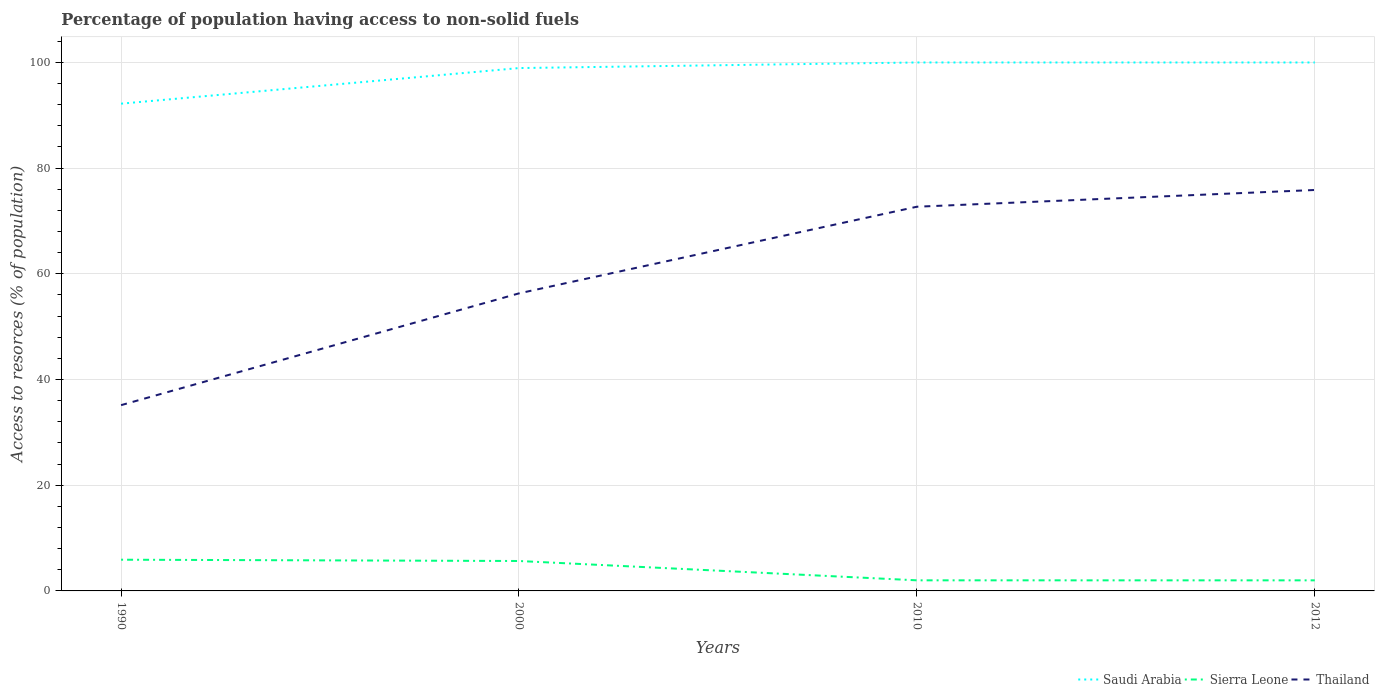How many different coloured lines are there?
Offer a very short reply. 3. Across all years, what is the maximum percentage of population having access to non-solid fuels in Sierra Leone?
Ensure brevity in your answer.  2. In which year was the percentage of population having access to non-solid fuels in Thailand maximum?
Make the answer very short. 1990. What is the total percentage of population having access to non-solid fuels in Thailand in the graph?
Your response must be concise. -19.56. What is the difference between the highest and the second highest percentage of population having access to non-solid fuels in Thailand?
Make the answer very short. 40.71. Is the percentage of population having access to non-solid fuels in Sierra Leone strictly greater than the percentage of population having access to non-solid fuels in Thailand over the years?
Your response must be concise. Yes. How many years are there in the graph?
Offer a very short reply. 4. Are the values on the major ticks of Y-axis written in scientific E-notation?
Keep it short and to the point. No. Does the graph contain any zero values?
Your answer should be compact. No. Does the graph contain grids?
Offer a terse response. Yes. How are the legend labels stacked?
Offer a terse response. Horizontal. What is the title of the graph?
Provide a succinct answer. Percentage of population having access to non-solid fuels. Does "Palau" appear as one of the legend labels in the graph?
Your answer should be compact. No. What is the label or title of the Y-axis?
Offer a terse response. Access to resorces (% of population). What is the Access to resorces (% of population) in Saudi Arabia in 1990?
Make the answer very short. 92.2. What is the Access to resorces (% of population) of Sierra Leone in 1990?
Keep it short and to the point. 5.91. What is the Access to resorces (% of population) in Thailand in 1990?
Make the answer very short. 35.15. What is the Access to resorces (% of population) in Saudi Arabia in 2000?
Provide a short and direct response. 98.93. What is the Access to resorces (% of population) in Sierra Leone in 2000?
Offer a very short reply. 5.66. What is the Access to resorces (% of population) in Thailand in 2000?
Provide a short and direct response. 56.3. What is the Access to resorces (% of population) in Saudi Arabia in 2010?
Keep it short and to the point. 99.99. What is the Access to resorces (% of population) in Sierra Leone in 2010?
Ensure brevity in your answer.  2. What is the Access to resorces (% of population) of Thailand in 2010?
Provide a succinct answer. 72.7. What is the Access to resorces (% of population) of Saudi Arabia in 2012?
Keep it short and to the point. 99.99. What is the Access to resorces (% of population) in Sierra Leone in 2012?
Provide a short and direct response. 2. What is the Access to resorces (% of population) of Thailand in 2012?
Provide a succinct answer. 75.86. Across all years, what is the maximum Access to resorces (% of population) of Saudi Arabia?
Your answer should be compact. 99.99. Across all years, what is the maximum Access to resorces (% of population) of Sierra Leone?
Offer a terse response. 5.91. Across all years, what is the maximum Access to resorces (% of population) of Thailand?
Give a very brief answer. 75.86. Across all years, what is the minimum Access to resorces (% of population) of Saudi Arabia?
Provide a succinct answer. 92.2. Across all years, what is the minimum Access to resorces (% of population) of Sierra Leone?
Keep it short and to the point. 2. Across all years, what is the minimum Access to resorces (% of population) of Thailand?
Offer a terse response. 35.15. What is the total Access to resorces (% of population) of Saudi Arabia in the graph?
Keep it short and to the point. 391.11. What is the total Access to resorces (% of population) of Sierra Leone in the graph?
Give a very brief answer. 15.57. What is the total Access to resorces (% of population) of Thailand in the graph?
Keep it short and to the point. 240.01. What is the difference between the Access to resorces (% of population) in Saudi Arabia in 1990 and that in 2000?
Your answer should be very brief. -6.74. What is the difference between the Access to resorces (% of population) in Sierra Leone in 1990 and that in 2000?
Keep it short and to the point. 0.24. What is the difference between the Access to resorces (% of population) in Thailand in 1990 and that in 2000?
Give a very brief answer. -21.15. What is the difference between the Access to resorces (% of population) in Saudi Arabia in 1990 and that in 2010?
Offer a very short reply. -7.79. What is the difference between the Access to resorces (% of population) of Sierra Leone in 1990 and that in 2010?
Provide a short and direct response. 3.9. What is the difference between the Access to resorces (% of population) of Thailand in 1990 and that in 2010?
Offer a terse response. -37.54. What is the difference between the Access to resorces (% of population) of Saudi Arabia in 1990 and that in 2012?
Offer a very short reply. -7.79. What is the difference between the Access to resorces (% of population) of Sierra Leone in 1990 and that in 2012?
Provide a short and direct response. 3.91. What is the difference between the Access to resorces (% of population) in Thailand in 1990 and that in 2012?
Your answer should be compact. -40.71. What is the difference between the Access to resorces (% of population) of Saudi Arabia in 2000 and that in 2010?
Give a very brief answer. -1.06. What is the difference between the Access to resorces (% of population) in Sierra Leone in 2000 and that in 2010?
Offer a terse response. 3.66. What is the difference between the Access to resorces (% of population) in Thailand in 2000 and that in 2010?
Make the answer very short. -16.39. What is the difference between the Access to resorces (% of population) of Saudi Arabia in 2000 and that in 2012?
Keep it short and to the point. -1.06. What is the difference between the Access to resorces (% of population) of Sierra Leone in 2000 and that in 2012?
Provide a short and direct response. 3.66. What is the difference between the Access to resorces (% of population) of Thailand in 2000 and that in 2012?
Offer a very short reply. -19.56. What is the difference between the Access to resorces (% of population) in Saudi Arabia in 2010 and that in 2012?
Make the answer very short. 0. What is the difference between the Access to resorces (% of population) of Sierra Leone in 2010 and that in 2012?
Keep it short and to the point. 0. What is the difference between the Access to resorces (% of population) in Thailand in 2010 and that in 2012?
Your answer should be very brief. -3.17. What is the difference between the Access to resorces (% of population) in Saudi Arabia in 1990 and the Access to resorces (% of population) in Sierra Leone in 2000?
Give a very brief answer. 86.53. What is the difference between the Access to resorces (% of population) of Saudi Arabia in 1990 and the Access to resorces (% of population) of Thailand in 2000?
Make the answer very short. 35.89. What is the difference between the Access to resorces (% of population) of Sierra Leone in 1990 and the Access to resorces (% of population) of Thailand in 2000?
Offer a terse response. -50.39. What is the difference between the Access to resorces (% of population) in Saudi Arabia in 1990 and the Access to resorces (% of population) in Sierra Leone in 2010?
Ensure brevity in your answer.  90.19. What is the difference between the Access to resorces (% of population) in Sierra Leone in 1990 and the Access to resorces (% of population) in Thailand in 2010?
Offer a very short reply. -66.79. What is the difference between the Access to resorces (% of population) of Saudi Arabia in 1990 and the Access to resorces (% of population) of Sierra Leone in 2012?
Provide a succinct answer. 90.2. What is the difference between the Access to resorces (% of population) of Saudi Arabia in 1990 and the Access to resorces (% of population) of Thailand in 2012?
Your response must be concise. 16.33. What is the difference between the Access to resorces (% of population) of Sierra Leone in 1990 and the Access to resorces (% of population) of Thailand in 2012?
Offer a terse response. -69.96. What is the difference between the Access to resorces (% of population) of Saudi Arabia in 2000 and the Access to resorces (% of population) of Sierra Leone in 2010?
Give a very brief answer. 96.93. What is the difference between the Access to resorces (% of population) in Saudi Arabia in 2000 and the Access to resorces (% of population) in Thailand in 2010?
Ensure brevity in your answer.  26.24. What is the difference between the Access to resorces (% of population) in Sierra Leone in 2000 and the Access to resorces (% of population) in Thailand in 2010?
Provide a succinct answer. -67.03. What is the difference between the Access to resorces (% of population) in Saudi Arabia in 2000 and the Access to resorces (% of population) in Sierra Leone in 2012?
Your response must be concise. 96.93. What is the difference between the Access to resorces (% of population) of Saudi Arabia in 2000 and the Access to resorces (% of population) of Thailand in 2012?
Your answer should be very brief. 23.07. What is the difference between the Access to resorces (% of population) of Sierra Leone in 2000 and the Access to resorces (% of population) of Thailand in 2012?
Provide a short and direct response. -70.2. What is the difference between the Access to resorces (% of population) in Saudi Arabia in 2010 and the Access to resorces (% of population) in Sierra Leone in 2012?
Ensure brevity in your answer.  97.99. What is the difference between the Access to resorces (% of population) of Saudi Arabia in 2010 and the Access to resorces (% of population) of Thailand in 2012?
Make the answer very short. 24.13. What is the difference between the Access to resorces (% of population) of Sierra Leone in 2010 and the Access to resorces (% of population) of Thailand in 2012?
Provide a succinct answer. -73.86. What is the average Access to resorces (% of population) in Saudi Arabia per year?
Offer a very short reply. 97.78. What is the average Access to resorces (% of population) in Sierra Leone per year?
Your answer should be compact. 3.89. What is the average Access to resorces (% of population) in Thailand per year?
Offer a very short reply. 60. In the year 1990, what is the difference between the Access to resorces (% of population) in Saudi Arabia and Access to resorces (% of population) in Sierra Leone?
Offer a very short reply. 86.29. In the year 1990, what is the difference between the Access to resorces (% of population) of Saudi Arabia and Access to resorces (% of population) of Thailand?
Give a very brief answer. 57.04. In the year 1990, what is the difference between the Access to resorces (% of population) in Sierra Leone and Access to resorces (% of population) in Thailand?
Give a very brief answer. -29.25. In the year 2000, what is the difference between the Access to resorces (% of population) in Saudi Arabia and Access to resorces (% of population) in Sierra Leone?
Provide a succinct answer. 93.27. In the year 2000, what is the difference between the Access to resorces (% of population) in Saudi Arabia and Access to resorces (% of population) in Thailand?
Give a very brief answer. 42.63. In the year 2000, what is the difference between the Access to resorces (% of population) in Sierra Leone and Access to resorces (% of population) in Thailand?
Offer a very short reply. -50.64. In the year 2010, what is the difference between the Access to resorces (% of population) of Saudi Arabia and Access to resorces (% of population) of Sierra Leone?
Keep it short and to the point. 97.99. In the year 2010, what is the difference between the Access to resorces (% of population) in Saudi Arabia and Access to resorces (% of population) in Thailand?
Your answer should be compact. 27.29. In the year 2010, what is the difference between the Access to resorces (% of population) in Sierra Leone and Access to resorces (% of population) in Thailand?
Give a very brief answer. -70.69. In the year 2012, what is the difference between the Access to resorces (% of population) of Saudi Arabia and Access to resorces (% of population) of Sierra Leone?
Your answer should be very brief. 97.99. In the year 2012, what is the difference between the Access to resorces (% of population) of Saudi Arabia and Access to resorces (% of population) of Thailand?
Your answer should be compact. 24.13. In the year 2012, what is the difference between the Access to resorces (% of population) of Sierra Leone and Access to resorces (% of population) of Thailand?
Provide a succinct answer. -73.86. What is the ratio of the Access to resorces (% of population) of Saudi Arabia in 1990 to that in 2000?
Your response must be concise. 0.93. What is the ratio of the Access to resorces (% of population) of Sierra Leone in 1990 to that in 2000?
Give a very brief answer. 1.04. What is the ratio of the Access to resorces (% of population) of Thailand in 1990 to that in 2000?
Your answer should be compact. 0.62. What is the ratio of the Access to resorces (% of population) in Saudi Arabia in 1990 to that in 2010?
Your answer should be very brief. 0.92. What is the ratio of the Access to resorces (% of population) in Sierra Leone in 1990 to that in 2010?
Offer a very short reply. 2.95. What is the ratio of the Access to resorces (% of population) in Thailand in 1990 to that in 2010?
Your response must be concise. 0.48. What is the ratio of the Access to resorces (% of population) in Saudi Arabia in 1990 to that in 2012?
Provide a short and direct response. 0.92. What is the ratio of the Access to resorces (% of population) of Sierra Leone in 1990 to that in 2012?
Keep it short and to the point. 2.95. What is the ratio of the Access to resorces (% of population) of Thailand in 1990 to that in 2012?
Your answer should be very brief. 0.46. What is the ratio of the Access to resorces (% of population) in Saudi Arabia in 2000 to that in 2010?
Offer a very short reply. 0.99. What is the ratio of the Access to resorces (% of population) in Sierra Leone in 2000 to that in 2010?
Your answer should be compact. 2.82. What is the ratio of the Access to resorces (% of population) in Thailand in 2000 to that in 2010?
Give a very brief answer. 0.77. What is the ratio of the Access to resorces (% of population) in Sierra Leone in 2000 to that in 2012?
Offer a terse response. 2.83. What is the ratio of the Access to resorces (% of population) of Thailand in 2000 to that in 2012?
Offer a very short reply. 0.74. What is the ratio of the Access to resorces (% of population) in Saudi Arabia in 2010 to that in 2012?
Provide a succinct answer. 1. What is the ratio of the Access to resorces (% of population) in Sierra Leone in 2010 to that in 2012?
Offer a very short reply. 1. What is the difference between the highest and the second highest Access to resorces (% of population) in Sierra Leone?
Your answer should be compact. 0.24. What is the difference between the highest and the second highest Access to resorces (% of population) in Thailand?
Keep it short and to the point. 3.17. What is the difference between the highest and the lowest Access to resorces (% of population) of Saudi Arabia?
Your answer should be very brief. 7.79. What is the difference between the highest and the lowest Access to resorces (% of population) in Sierra Leone?
Your answer should be compact. 3.91. What is the difference between the highest and the lowest Access to resorces (% of population) in Thailand?
Provide a succinct answer. 40.71. 